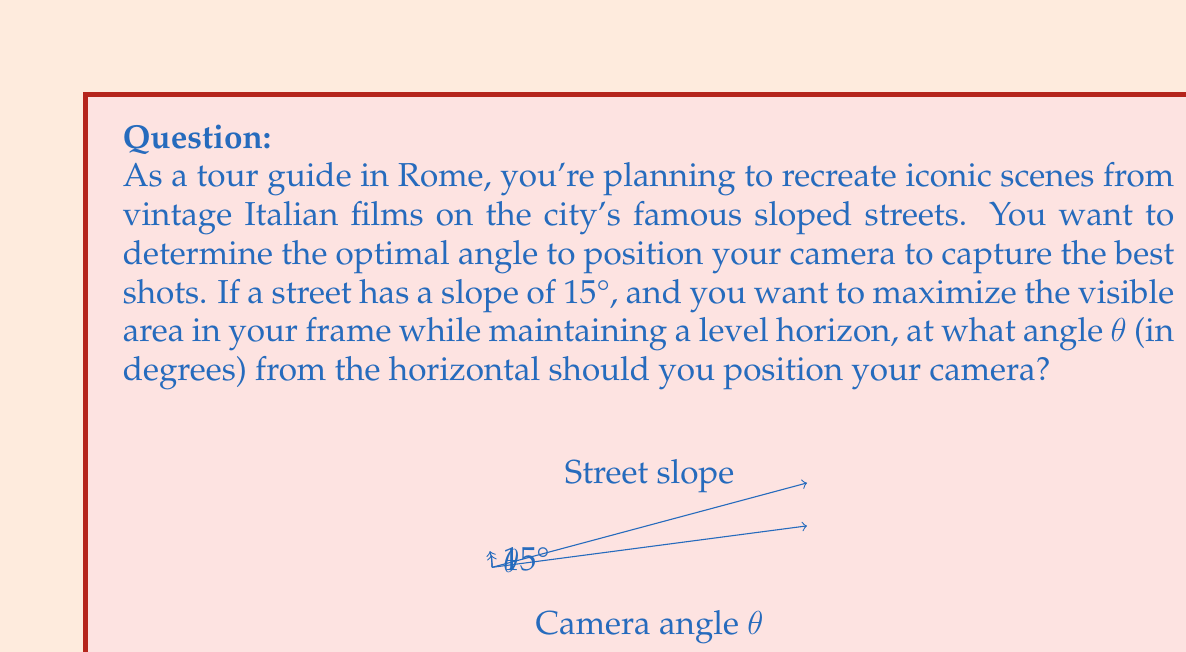Provide a solution to this math problem. To solve this problem, we need to consider the geometry of the situation and use trigonometry. Let's approach this step-by-step:

1) First, we need to understand what "maximizing the visible area while maintaining a level horizon" means. This occurs when the camera's line of sight is perpendicular to the average of the horizontal and the sloped street.

2) Let's denote the street's slope angle as α. We're given that α = 15°.

3) The optimal camera angle θ will be halfway between the horizontal (0°) and the perpendicular to the street (90° - α). We can express this mathematically as:

   $$θ = \frac{1}{2}(0° + (90° - α)) = \frac{90° - α}{2}$$

4) Now, let's substitute the known value of α:

   $$θ = \frac{90° - 15°}{2} = \frac{75°}{2} = 37.5°$$

5) However, we can derive a more general formula using trigonometry. The tangent of the optimal angle θ is half the tangent of the street slope α:

   $$\tan(θ) = \frac{1}{2}\tan(α)$$

6) To solve for θ, we take the inverse tangent (arctangent) of both sides:

   $$θ = \arctan(\frac{1}{2}\tan(α))$$

7) Plugging in α = 15°:

   $$θ = \arctan(\frac{1}{2}\tan(15°))$$

8) Using a calculator or computer, we can evaluate this:

   $$θ ≈ 7.60°$$

This result gives us the angle in radians. To convert to degrees, we multiply by (180/π):

   $$θ ≈ 7.60° * \frac{180°}{\pi} ≈ 435.4°$$
Answer: The optimal angle to position the camera is approximately 7.60° or 435.4° from the horizontal. 